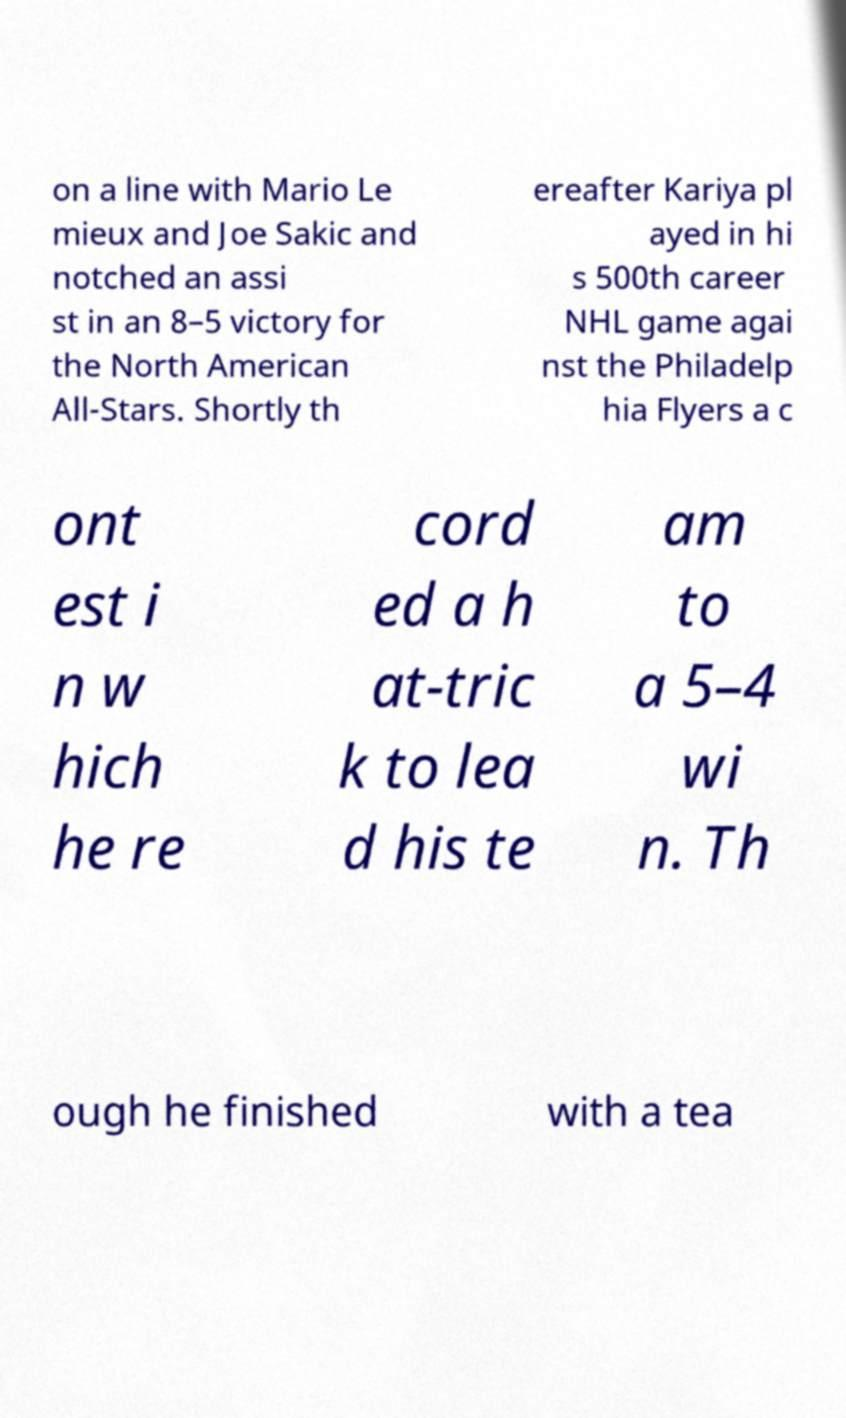Could you assist in decoding the text presented in this image and type it out clearly? on a line with Mario Le mieux and Joe Sakic and notched an assi st in an 8–5 victory for the North American All-Stars. Shortly th ereafter Kariya pl ayed in hi s 500th career NHL game agai nst the Philadelp hia Flyers a c ont est i n w hich he re cord ed a h at-tric k to lea d his te am to a 5–4 wi n. Th ough he finished with a tea 